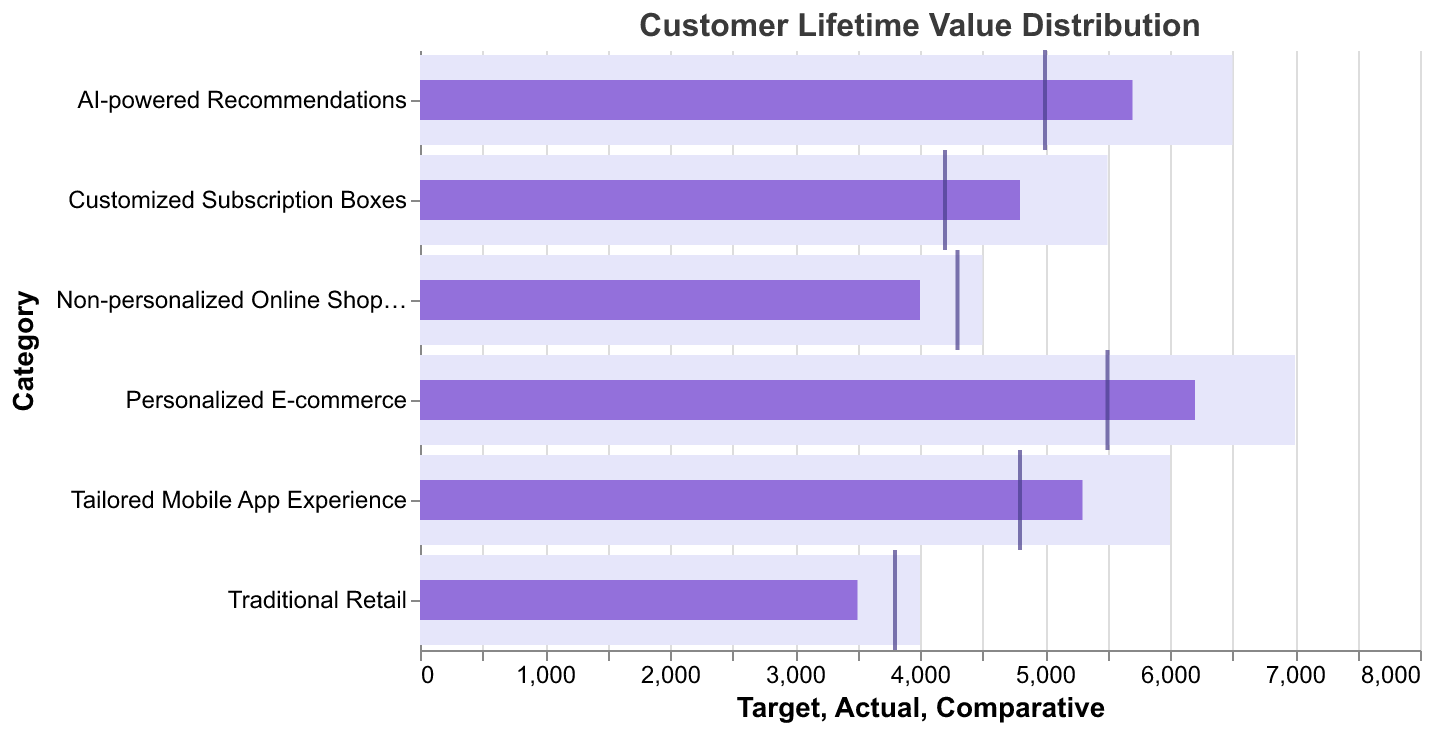What is the customer lifetime value in Personalized E-commerce compared to the target value? The target value for Personalized E-commerce is 7000. The actual customer lifetime value is 6200. Comparing these, the actual value is 6200 / 7000 or 88.6% of the target value.
Answer: 88.6% How do the Actual and Comparative values for Traditional Retail differ? The Actual value for Traditional Retail is 3500, while the Comparative value is 3800. The difference between the Comparative and Actual values is 3800 - 3500 = 300.
Answer: 300 Which category has the highest Actual customer lifetime value? According to the data, the category with the highest Actual value is Personalized E-commerce with 6200.
Answer: Personalized E-commerce What is the difference in Actual customer lifetime value between Personalized E-commerce and AI-powered Recommendations? Personalized E-commerce has an Actual value of 6200 and AI-powered Recommendations has an Actual value of 5700. The difference is 6200 - 5700 = 500.
Answer: 500 Which category has the lowest Comparative customer lifetime value? Among the categories, Customized Subscription Boxes has the lowest Comparative value of 4200.
Answer: Customized Subscription Boxes Is there any category where the Comparative value is greater than the Actual value? Yes, in Non-personalized Online Shopping, the Comparative value (4300) is greater than the Actual value (4000).
Answer: Non-personalized Online Shopping What is the average Target value across all categories? Summing all the Target values (7000, 5500, 6500, 4000, 4500, 6000) gives 33500. Dividing by the number of categories (6), the average is 33500 / 6 = 5583.3.
Answer: 5583.3 How close is the Actual value of Tailored Mobile App Experience to its Target value in percentage? The Target value is 6000, and the Actual value is 5300. The percentage is (5300 / 6000) * 100, which equals approximately 88.3%.
Answer: 88.3% Which category has surpassed its Target value in Actual customer lifetime value? None of the categories have an Actual value surpassing their respective Target values. All Actual values are less than their Target values.
Answer: None How does the Actual customer lifetime value of Customized Subscription Boxes compare to Non-personalized Online Shopping? The Actual value of Customized Subscription Boxes is 4800, while for Non-personalized Online Shopping it is 4000. The difference is 4800 - 4000 = 800.
Answer: 800 